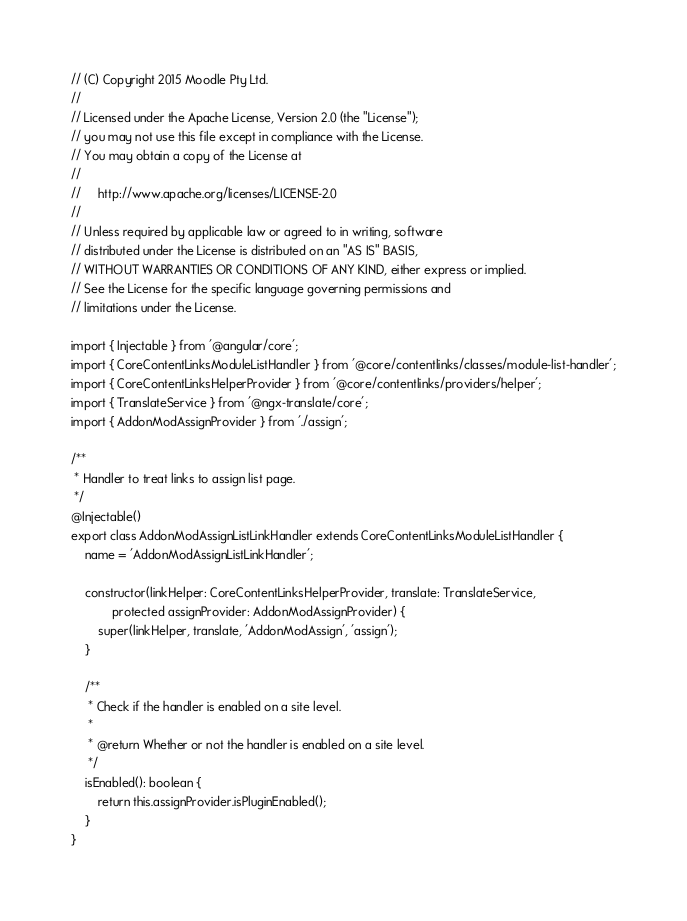<code> <loc_0><loc_0><loc_500><loc_500><_TypeScript_>// (C) Copyright 2015 Moodle Pty Ltd.
//
// Licensed under the Apache License, Version 2.0 (the "License");
// you may not use this file except in compliance with the License.
// You may obtain a copy of the License at
//
//     http://www.apache.org/licenses/LICENSE-2.0
//
// Unless required by applicable law or agreed to in writing, software
// distributed under the License is distributed on an "AS IS" BASIS,
// WITHOUT WARRANTIES OR CONDITIONS OF ANY KIND, either express or implied.
// See the License for the specific language governing permissions and
// limitations under the License.

import { Injectable } from '@angular/core';
import { CoreContentLinksModuleListHandler } from '@core/contentlinks/classes/module-list-handler';
import { CoreContentLinksHelperProvider } from '@core/contentlinks/providers/helper';
import { TranslateService } from '@ngx-translate/core';
import { AddonModAssignProvider } from './assign';

/**
 * Handler to treat links to assign list page.
 */
@Injectable()
export class AddonModAssignListLinkHandler extends CoreContentLinksModuleListHandler {
    name = 'AddonModAssignListLinkHandler';

    constructor(linkHelper: CoreContentLinksHelperProvider, translate: TranslateService,
            protected assignProvider: AddonModAssignProvider) {
        super(linkHelper, translate, 'AddonModAssign', 'assign');
    }

    /**
     * Check if the handler is enabled on a site level.
     *
     * @return Whether or not the handler is enabled on a site level.
     */
    isEnabled(): boolean {
        return this.assignProvider.isPluginEnabled();
    }
}
</code> 